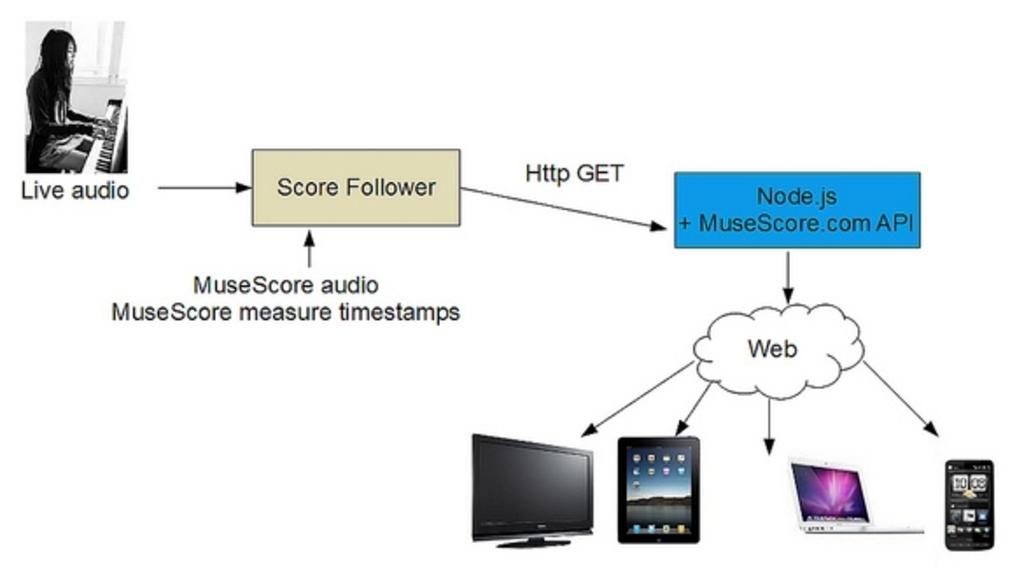What word is written in the cloud?
Ensure brevity in your answer.  Web. 